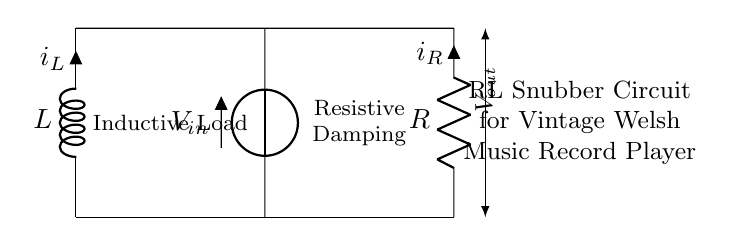What components are in the circuit? The circuit contains an inductor and a resistor, as labeled within the circuit diagram.
Answer: Inductor and resistor What is the input voltage of the circuit? The input voltage is labeled as V_in, indicating the source of voltage in the circuit at that point.
Answer: V_in What does the current through the inductor represent? The current through the inductor is represented as i_L, indicating the direction and magnitude of current flow through the inductor, which is energy-storing.
Answer: i_L What is the purpose of the resistor in this circuit? The resistor provides damping to the circuit by limiting current flow and dissipating energy as heat, thus controlling the behavior of the circuit.
Answer: Damping How does the arrangement of components affect inductive behavior? The series arrangement of the inductor and resistor allows the circuit to act as an RL circuit, influencing the time constant which determines how quickly the current builds up or decays in response to voltage changes.
Answer: Influences time constant What is the expected outcome when the circuit is used with an inductive load? When interfaced with an inductive load, the circuit will manage voltage spikes by smoothing out the current flow, hence preventing potential damage due to back EMF generated by inductors during abrupt changes in current.
Answer: Smooth current flow How do you identify the output voltage in the circuit? The output voltage, labeled as V_out in the circuit diagram, is indicated on the right side, showing the voltage across the resistor when connected to the output of the load.
Answer: V_out 